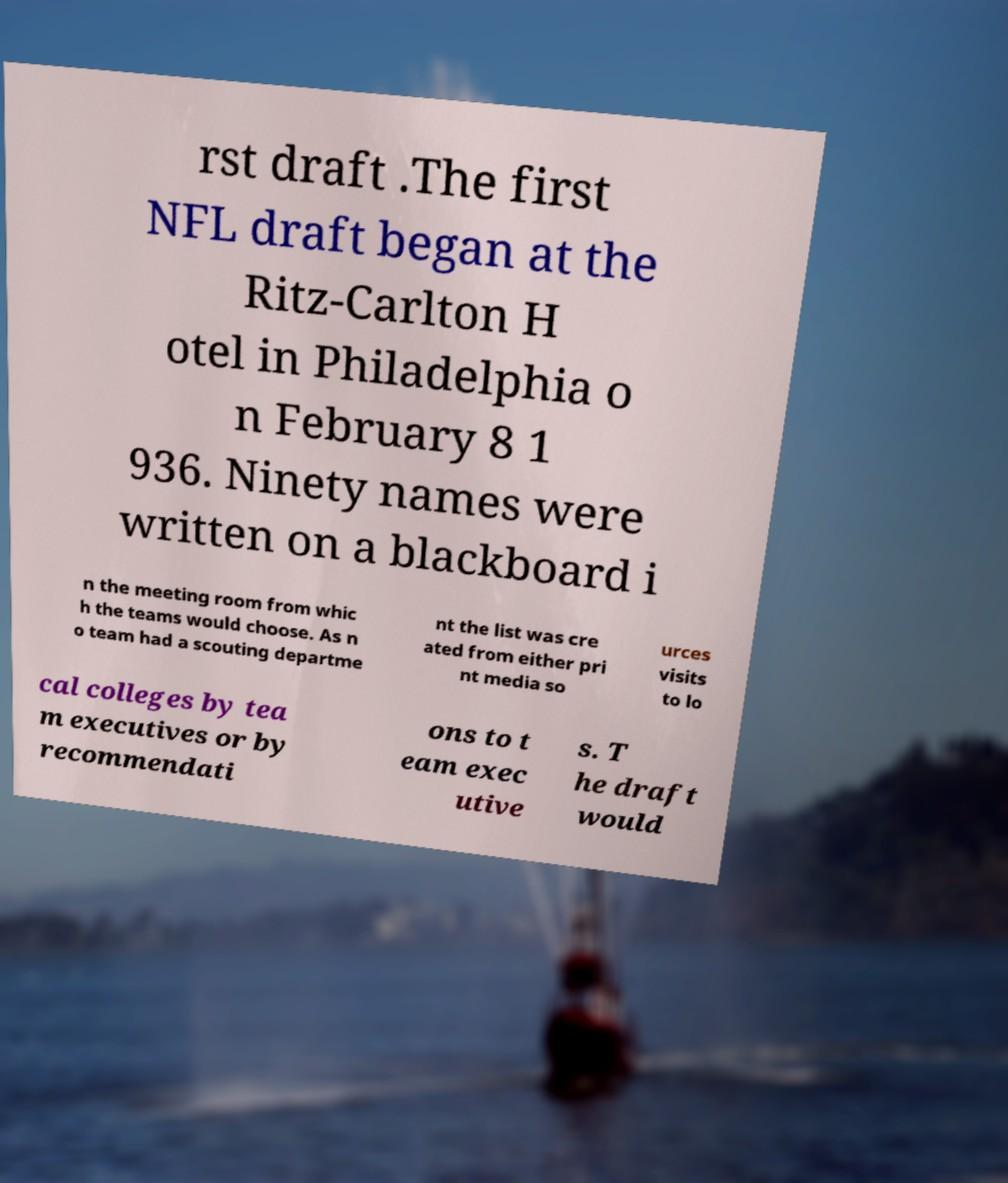Could you assist in decoding the text presented in this image and type it out clearly? rst draft .The first NFL draft began at the Ritz-Carlton H otel in Philadelphia o n February 8 1 936. Ninety names were written on a blackboard i n the meeting room from whic h the teams would choose. As n o team had a scouting departme nt the list was cre ated from either pri nt media so urces visits to lo cal colleges by tea m executives or by recommendati ons to t eam exec utive s. T he draft would 